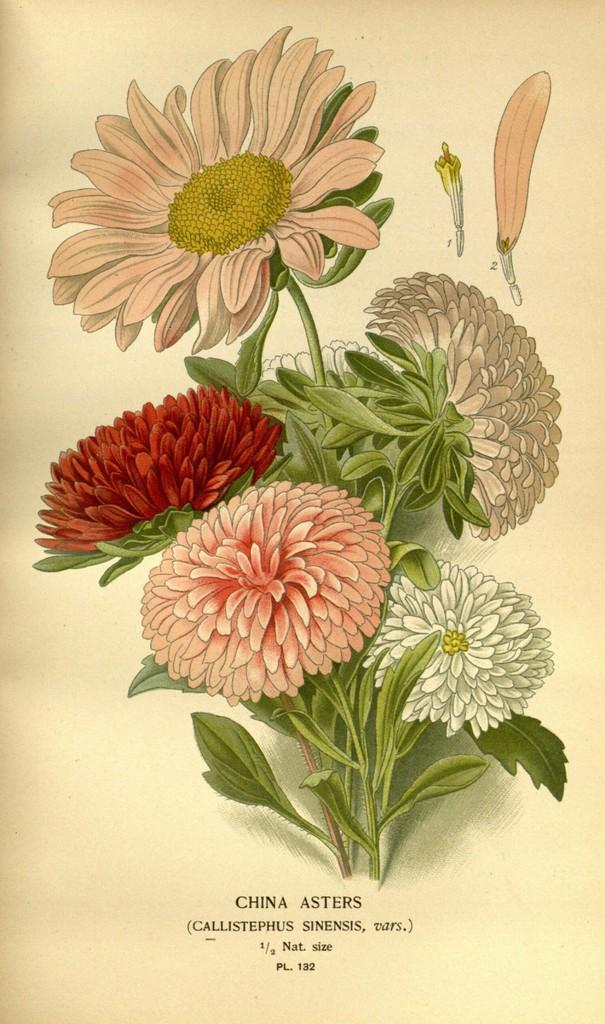What type of artwork is depicted in the image? The image is a painting. What is the main subject of the painting? The painting consists of flowers. Is there any text present in the painting? Yes, there is text at the bottom of the painting. Can you see any volcanoes erupting in the painting? There are no volcanoes present in the painting; it consists of flowers. Are there any police officers visible in the painting? There are no police officers depicted in the painting; it consists of flowers and text. 